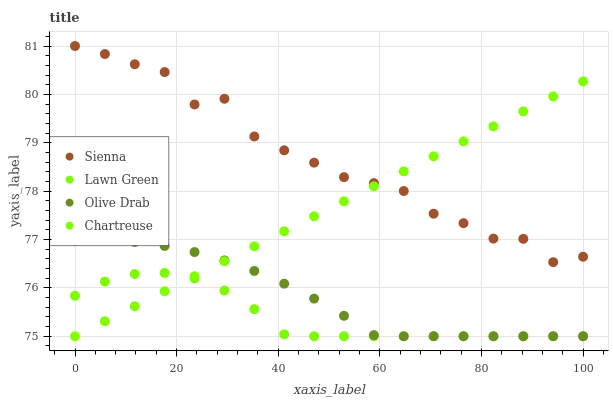Does Lawn Green have the minimum area under the curve?
Answer yes or no. Yes. Does Sienna have the maximum area under the curve?
Answer yes or no. Yes. Does Chartreuse have the minimum area under the curve?
Answer yes or no. No. Does Chartreuse have the maximum area under the curve?
Answer yes or no. No. Is Chartreuse the smoothest?
Answer yes or no. Yes. Is Sienna the roughest?
Answer yes or no. Yes. Is Lawn Green the smoothest?
Answer yes or no. No. Is Lawn Green the roughest?
Answer yes or no. No. Does Lawn Green have the lowest value?
Answer yes or no. Yes. Does Sienna have the highest value?
Answer yes or no. Yes. Does Chartreuse have the highest value?
Answer yes or no. No. Is Olive Drab less than Sienna?
Answer yes or no. Yes. Is Sienna greater than Olive Drab?
Answer yes or no. Yes. Does Olive Drab intersect Chartreuse?
Answer yes or no. Yes. Is Olive Drab less than Chartreuse?
Answer yes or no. No. Is Olive Drab greater than Chartreuse?
Answer yes or no. No. Does Olive Drab intersect Sienna?
Answer yes or no. No. 